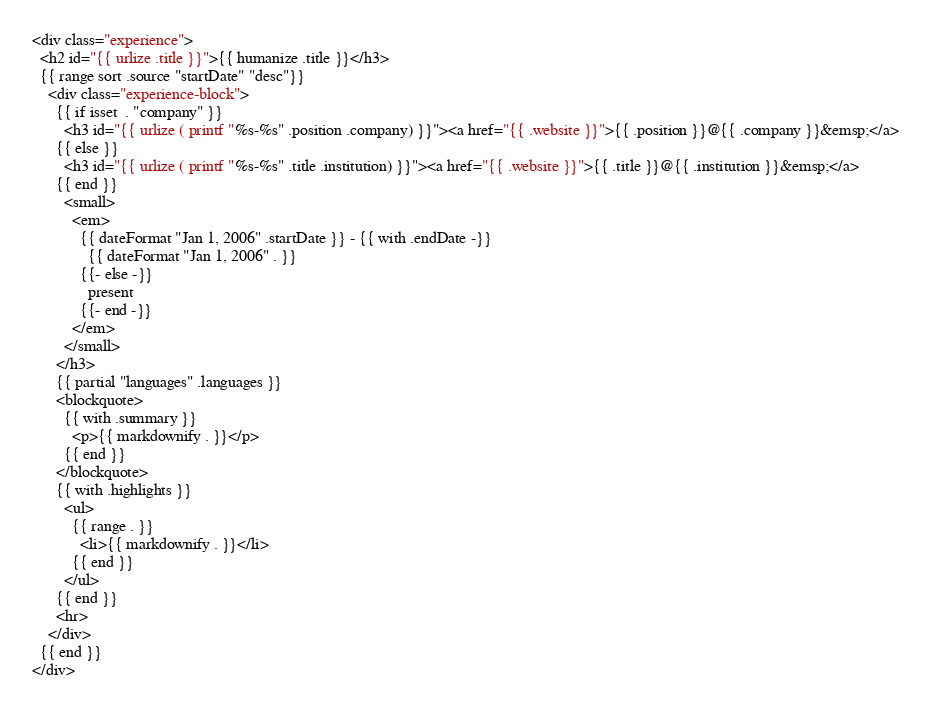<code> <loc_0><loc_0><loc_500><loc_500><_HTML_><div class="experience">
  <h2 id="{{ urlize .title }}">{{ humanize .title }}</h3>
  {{ range sort .source "startDate" "desc"}}
    <div class="experience-block">
      {{ if isset  . "company" }}
        <h3 id="{{ urlize ( printf "%s-%s" .position .company) }}"><a href="{{ .website }}">{{ .position }}@{{ .company }}&emsp;</a>
      {{ else }}
        <h3 id="{{ urlize ( printf "%s-%s" .title .institution) }}"><a href="{{ .website }}">{{ .title }}@{{ .institution }}&emsp;</a>
      {{ end }}
        <small>
          <em>
            {{ dateFormat "Jan 1, 2006" .startDate }} - {{ with .endDate -}}
              {{ dateFormat "Jan 1, 2006" . }}
            {{- else -}}
              present
            {{- end -}}
          </em>
        </small>
      </h3>
      {{ partial "languages" .languages }}
      <blockquote>
        {{ with .summary }}
          <p>{{ markdownify . }}</p>
        {{ end }}
      </blockquote>
      {{ with .highlights }}
        <ul>
          {{ range . }}
            <li>{{ markdownify . }}</li>
          {{ end }}
        </ul>
      {{ end }}
      <hr>
    </div>
  {{ end }}
</div>
</code> 